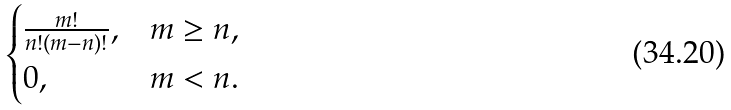<formula> <loc_0><loc_0><loc_500><loc_500>\begin{cases} \frac { m ! } { n ! ( m - n ) ! } , & m \geq n , \\ 0 , & m < n . \end{cases}</formula> 